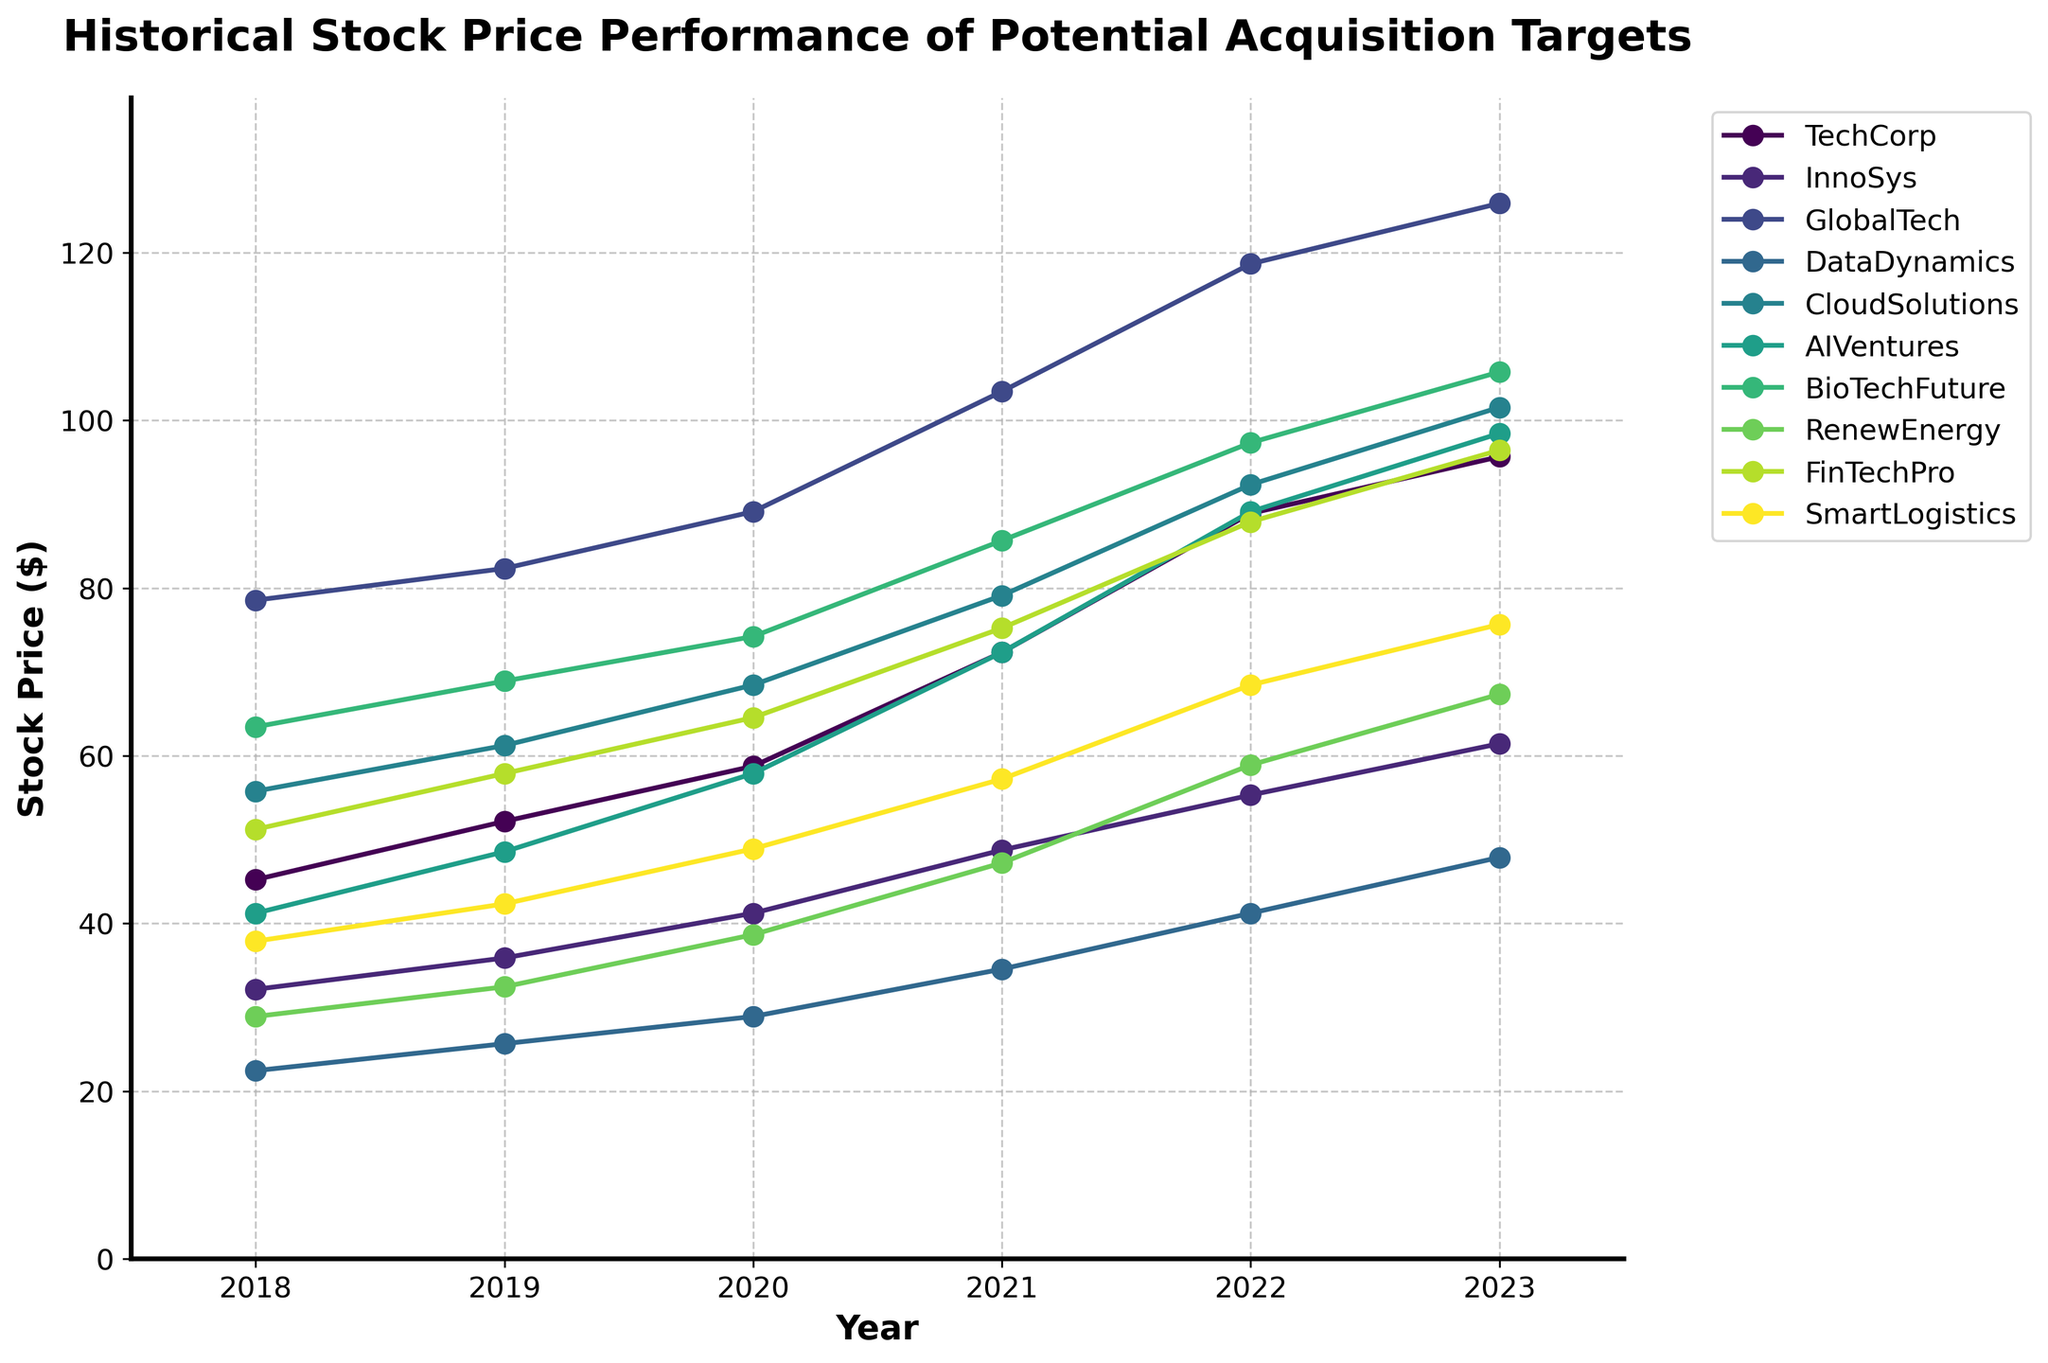Which company had the highest stock price in 2023? Look at the final data points for 2023 and identify the highest one. GlobalTech has the highest stock price at 125.89.
Answer: GlobalTech Which company exhibited the greatest percentage increase in stock price from 2018 to 2023? Calculate the percentage increase for each company: ((2023 price - 2018 price) / 2018 price) * 100, and compare them. DataDynamics had ((47.89 - 22.45) / 22.45) * 100 = 113.31% increase.
Answer: DataDynamics Which two companies had the closest stock prices in 2021? Compare the 2021 stock prices and find the two companies with the smallest difference. InnoSys and RenewEnergy had prices of 48.76 and 47.23 respectively, with a difference of 1.53.
Answer: InnoSys and RenewEnergy Which company's stock price increased continuously every year from 2018 to 2023? Examine the trend of each company's stock price over the years to determine which one has consistently increased. All companies show a continuous increase.
Answer: All companies What was the average stock price of CloudSolutions over the 5 years? Sum CloudSolutions' stock prices from 2018 to 2023 and divide by the number of years: (55.78 + 61.23 + 68.45 + 79.12 + 92.34 + 101.56) / 6 = 76.75.
Answer: 76.75 How many companies had a stock price above $100 in 2023? Check the final data points for 2023 and count how many are above 100. Three companies (GlobalTech, BioTechFuture, and CloudSolutions) had stock prices above $100 in 2023.
Answer: 3 Which company had the smallest stock price increase from 2022 to 2023? Calculate the difference between 2023 and 2022 for each company, and identify the smallest. InnoSys had the smallest increase from 55.32 to 61.45, a difference of 6.13.
Answer: InnoSys Which company had a higher stock price in 2019 compared to GlobalTech but lower in 2023? Find companies whose 2019 stock price is above GlobalTech's 82.34 but below its 2023 price of 125.89. AI Ventures fits this criterion (48.56 in 2019 and 98.45 in 2023).
Answer: AI Ventures What was the combined stock price of BioTechFuture and FinTechPro in 2020? Sum the stock prices of BioTechFuture and FinTechPro for 2020 (74.23 + 64.56 = 138.79).
Answer: 138.79 Which company showed the most significant stock price growth between two consecutive years? Compare the year-to-year growth for each company over the years 2018-2023 and find the largest increase. GlobalTech had a significant increase between 2020 to 2021 (103.45 - 89.12 = 14.33).
Answer: GlobalTech 